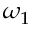<formula> <loc_0><loc_0><loc_500><loc_500>\omega _ { 1 }</formula> 